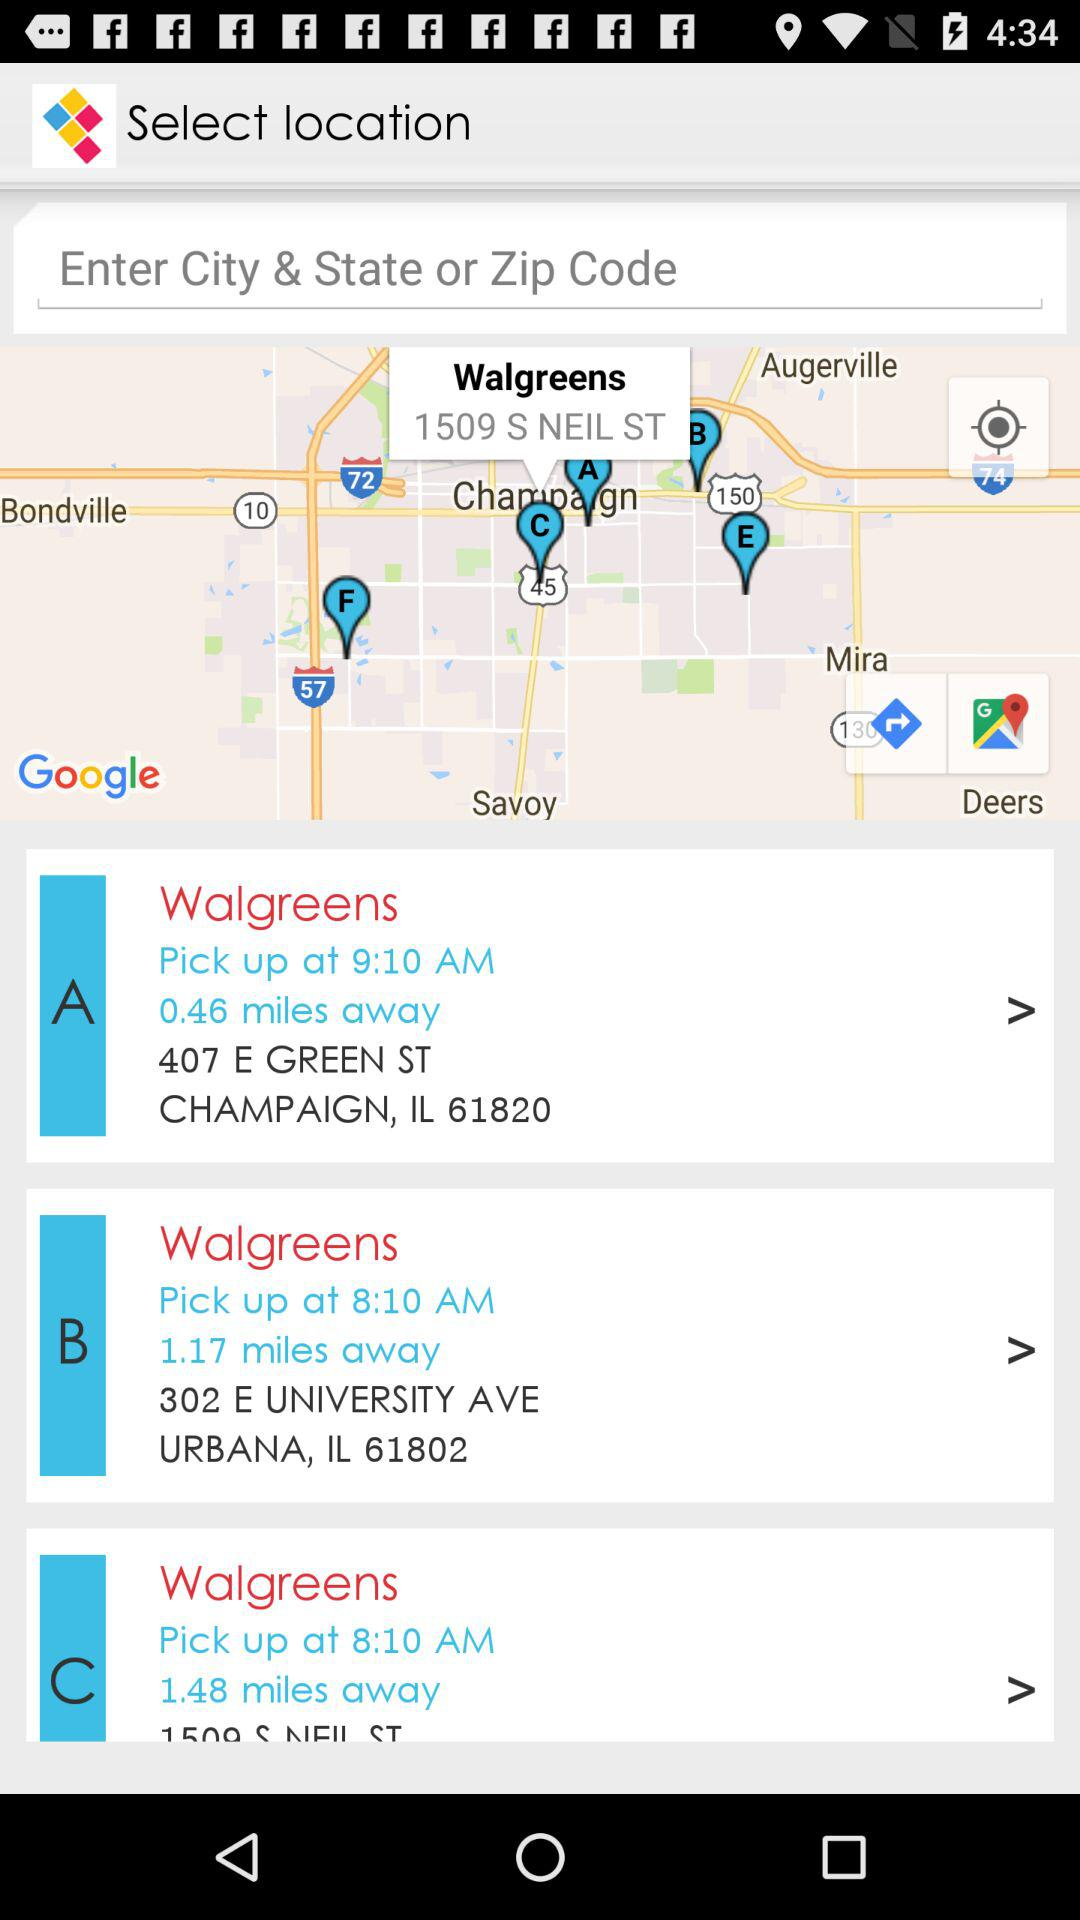What is the pick-up time from "Walgreens"? The pick-up times are 9:10 a.m. and 8:10 a.m. 